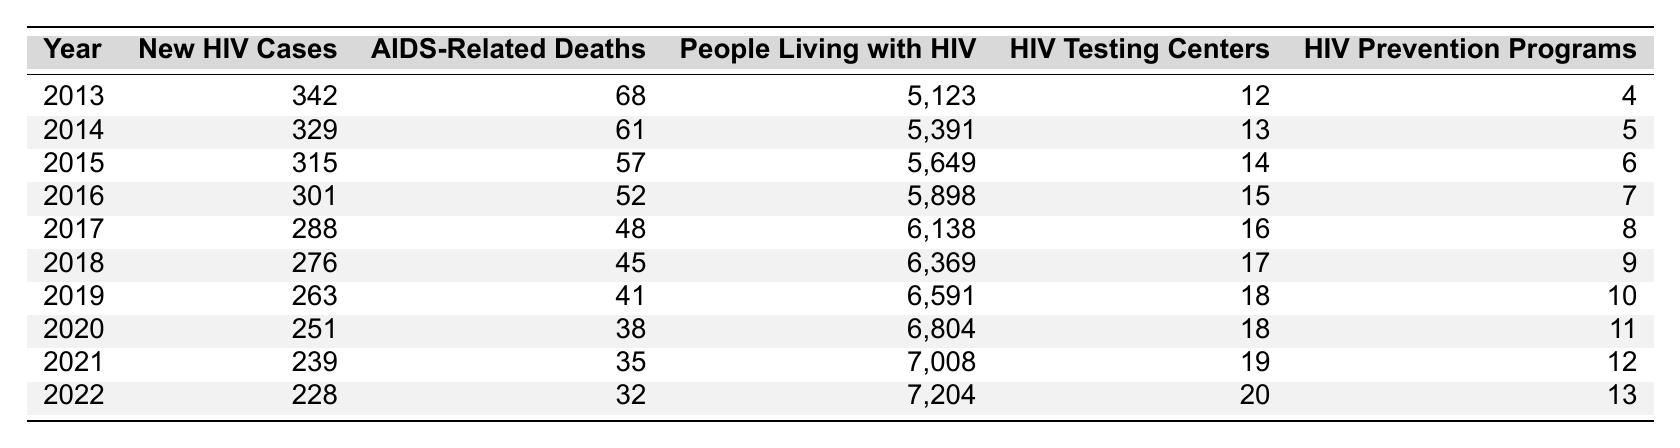What was the number of new HIV cases in Columbus in 2016? According to the table, the number of new HIV cases reported in 2016 was directly listed as 301.
Answer: 301 How many AIDS-related deaths occurred in 2019? The table shows that there were 41 AIDS-related deaths in the year 2019.
Answer: 41 What is the total number of people living with HIV from 2013 to 2022? To find the total, you sum all the values from the "People Living with HIV" column: 5123 + 5391 + 5649 + 5898 + 6138 + 6369 + 6591 + 6804 + 7008 + 7204 = 61,075.
Answer: 61075 In which year did the number of new HIV cases drop below 300? The first year in the table where new HIV cases dropped below 300 is 2017, when there were 288 new cases.
Answer: 2017 What was the average number of AIDS-related deaths from 2013 to 2022? To find the average, sum the deaths from the "AIDS-Related Deaths" column: 68 + 61 + 57 + 52 + 48 + 45 + 41 + 38 + 35 + 32 =  435. Then, divide by the number of years (10): 435/10 = 43.5.
Answer: 43.5 Was there a year where the number of HIV testing centers was fewer than 15? By looking at the "HIV Testing Centers" column, it can be observed that every year from 2013 to 2016 had fewer than 15 testing centers, confirming that this is true.
Answer: Yes What is the trend in the number of new HIV cases over the decade? By examining the "New HIV Cases" column, it can be seen that the number of new cases has decreased each year from 2013 to 2022, indicating a consistent downward trend.
Answer: Decreasing In 2021, how many more people were living with HIV compared to 2013? The number of people living with HIV in 2021 was 7008, and in 2013 it was 5123. The difference is 7008 - 5123 = 1885.
Answer: 1885 What was the year with the highest number of HIV prevention programs? The table indicates that 2022 had the highest number of HIV prevention programs at 13.
Answer: 2022 Based on the data, does the number of HIV testing centers increase every year? By analyzing the "HIV Testing Centers" column, it shows an increase every year, confirming that this statement is true.
Answer: Yes 